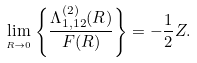Convert formula to latex. <formula><loc_0><loc_0><loc_500><loc_500>\lim _ { _ { R \rightarrow 0 } } \left \{ \frac { \Lambda _ { 1 , 1 2 } ^ { ( 2 ) } ( R ) } { F ( R ) } \right \} = - \frac { 1 } { 2 } Z .</formula> 